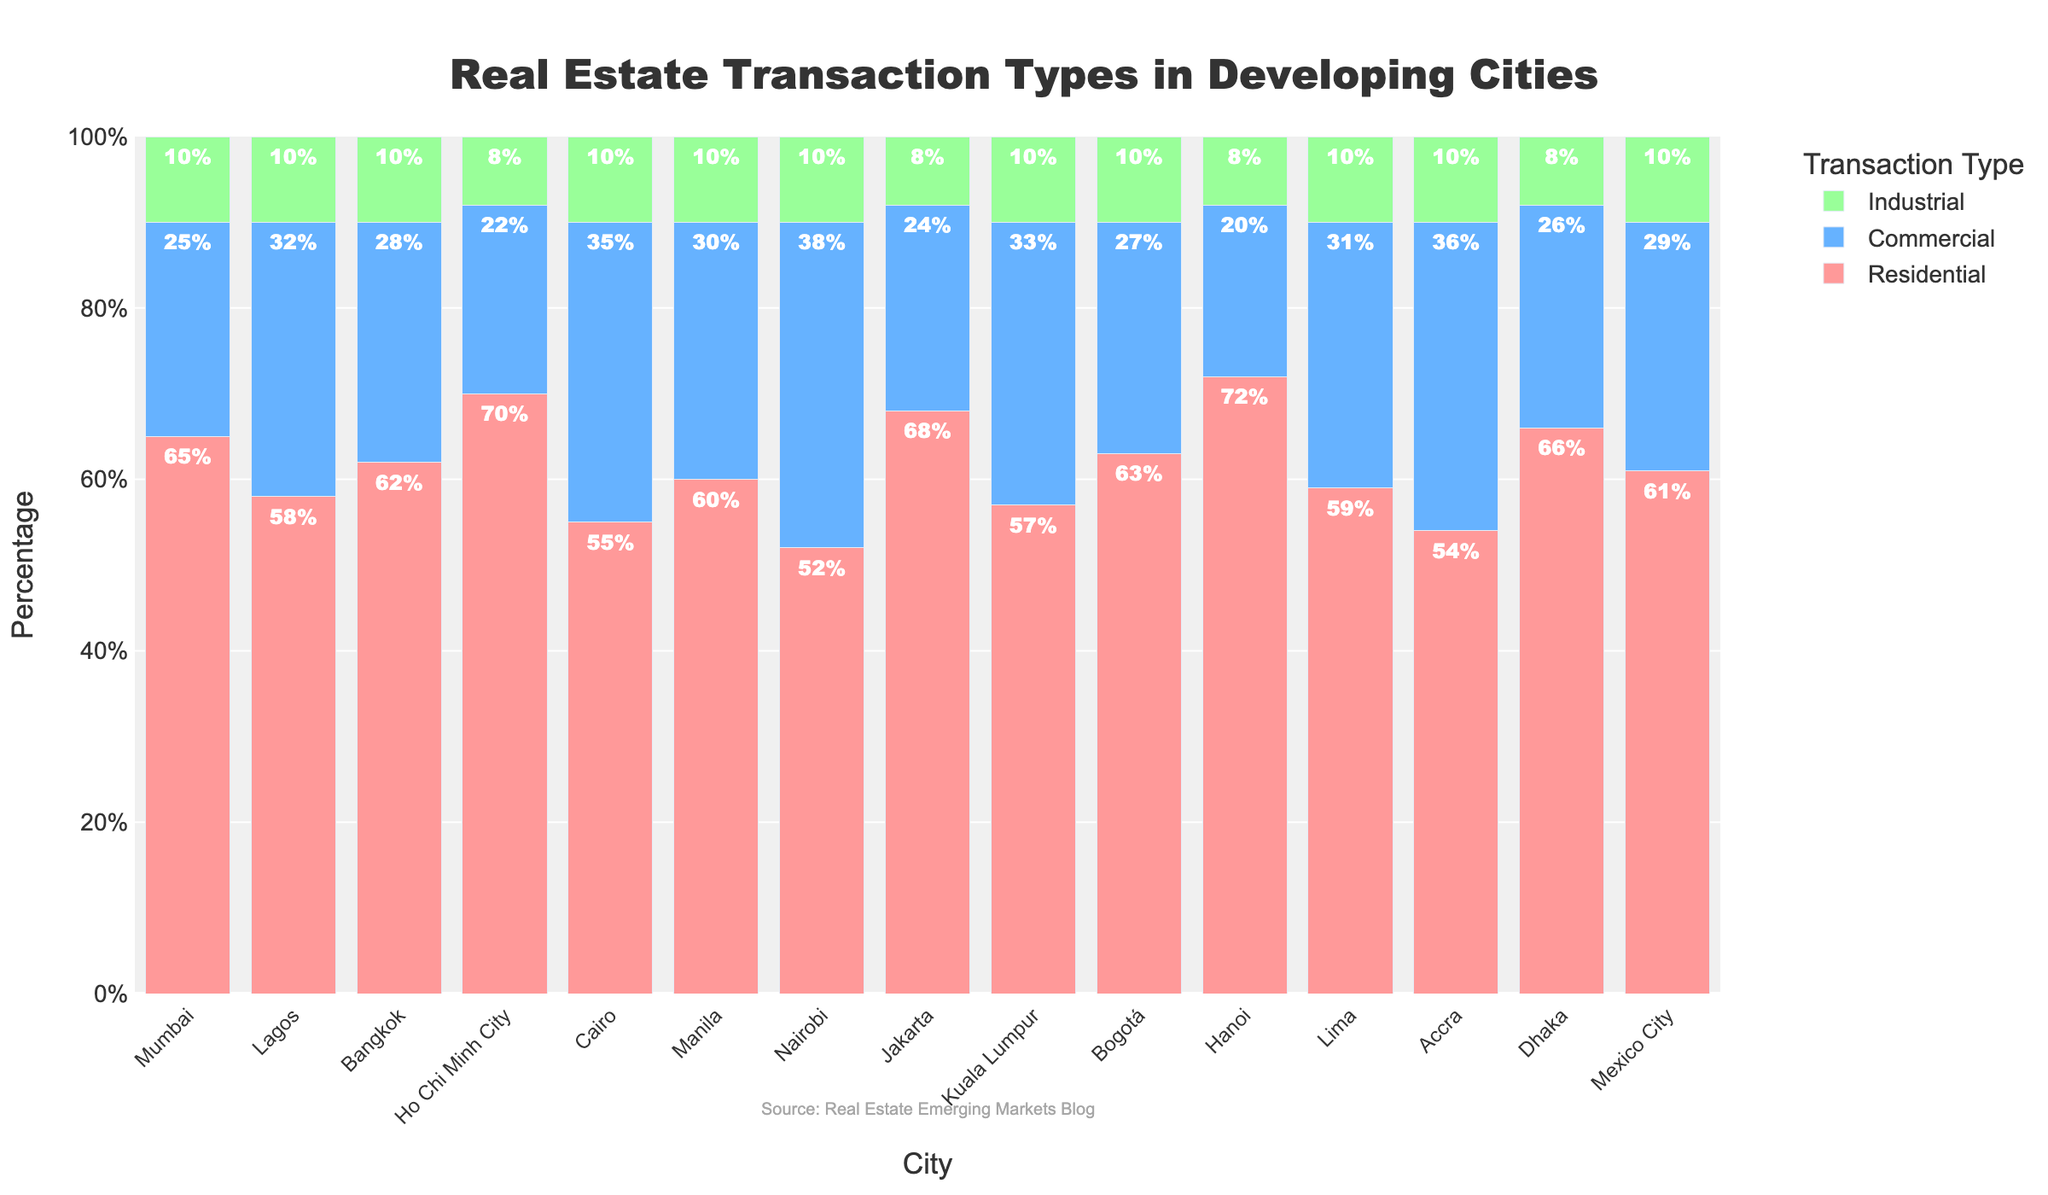How does the proportion of residential transactions in Bangkok compare to those in Nairobi? To find this, look at the residential transaction percentages. Bangkok has 62%, and Nairobi has 52%. Comparing the two values, 62% is higher than 52%.
Answer: Bangkok has a higher proportion Which city has the highest percentage of industrial transactions? Review each city's industrial transactions. The percentages are either 8% or 10%. No city exceeds 10% for industrial.
Answer: Multiple cities have the highest, 10% Which city has the lowest percentage of commercial transactions? Check the commercial transaction column. Hanoi, Ho Chi Minh City, and Jakarta each have 20% or below, specifically 20% or 22%. Hanoi has the lowest at 20%.
Answer: Hanoi What is the combined percentage of commercial and industrial transactions in Accra? Add the commercial and industrial transaction percentages for Accra. Commercial is 36%, and industrial is 10%. 36% + 10% = 46%.
Answer: 46% In which cities do residential transactions make up more than 65% of all transactions? Identify cities with residential percentages exceeding 65%. These include Mumbai (65%), Ho Chi Minh City (70%), Jakarta (68%), Hanoi (72%), and Dhaka (66%).
Answer: Mumbai, Ho Chi Minh City, Jakarta, Hanoi, Dhaka Compare the commercial transactions in Cairo and Lagos. Which city has a higher percentage? Refer to the commercial percentages. Cairo has 35%, and Lagos has 32%. Cairo's 35% is higher than Lagos's 32%.
Answer: Cairo What is the average percentage of residential transactions across all cities? Sum the residential percentages and divide by the number of cities. (65 + 58 + 62 + 70 + 55 + 60 + 52 + 68 + 57 + 63 + 72 + 59 + 54 + 66 + 61) / 15 = 828 / 15 ≈ 55.2%.
Answer: Approximately 55.2% Which city shows the same percentage for residential and industrial transactions? Look for cities where the residential and industrial percentages match. Ho Chi Minh City has 70% residential and 8% industrial, and neither percentage matches in any city.
Answer: None Compare the height of the residential bar for Jakarta with that of Kuala Lumpur. Which is taller? Check the heights of the residential bars. Jakarta's residential is 68%, and Kuala Lumpur's is 57%. 68% is taller than 57%.
Answer: Jakarta's is taller What is the total percentage for each transaction type in Lima? Add the respective percentages for residential, commercial, and industrial transactions in Lima. 59% (residential) + 31% (commercial) + 10% (industrial) = 100%.
Answer: 100% 